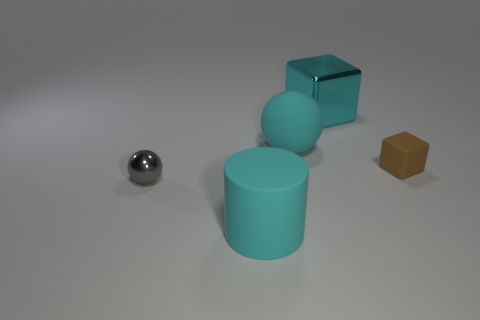Which object appears to be the heaviest, and why might that be? The metal block looks to be the heaviest due to its material and solid shape. Metals are typically denser and weightier than the other materials visible in the image, like plastic or rubber. 